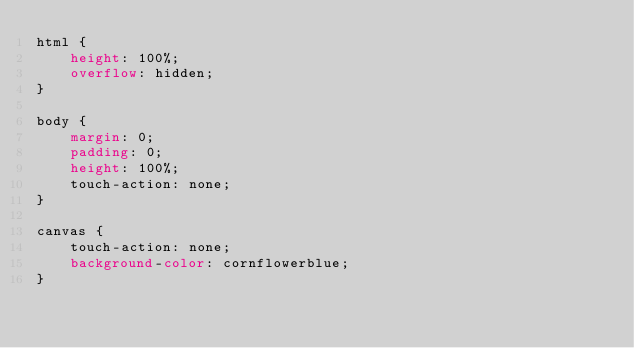Convert code to text. <code><loc_0><loc_0><loc_500><loc_500><_CSS_>html {
    height: 100%;
    overflow: hidden;
}

body {
    margin: 0;
    padding: 0;
    height: 100%;
    touch-action: none;
}

canvas {
    touch-action: none;
    background-color: cornflowerblue;
}
</code> 